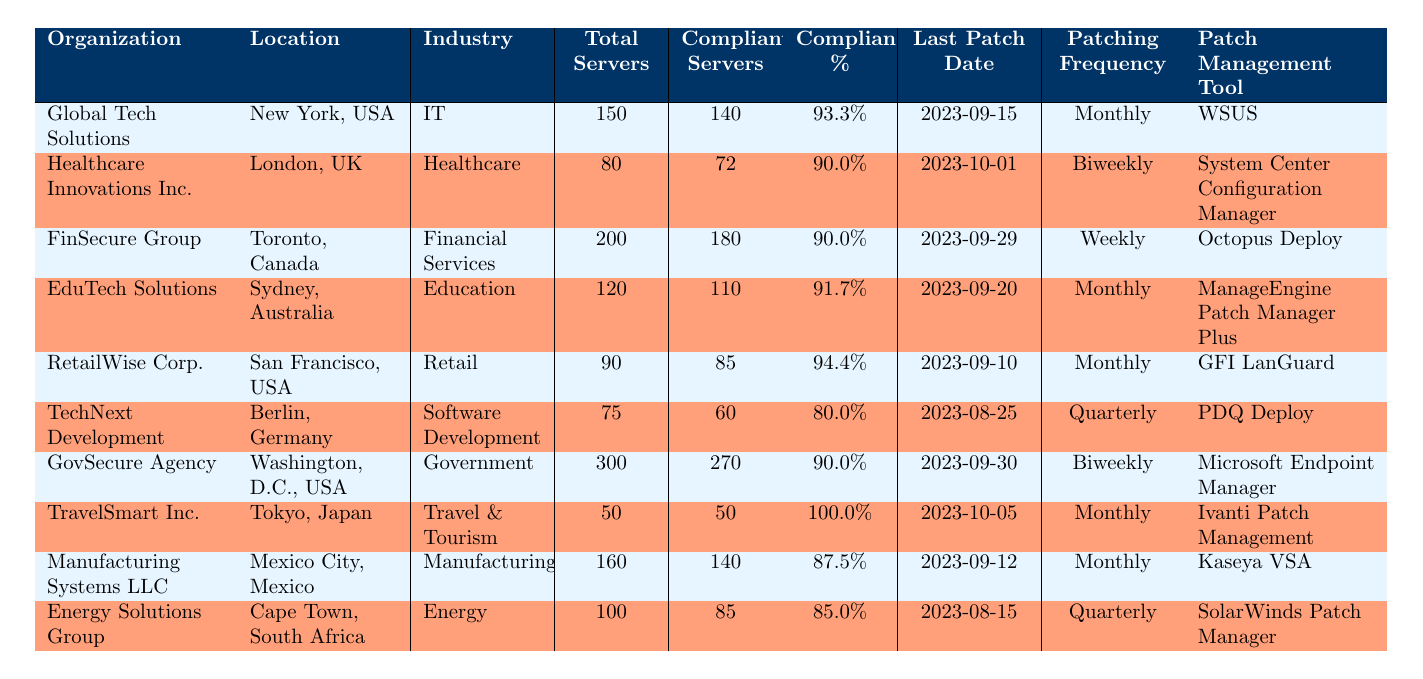What is the compliance percentage of Global Tech Solutions? The table shows "Global Tech Solutions" with a compliance percentage listed under the "Compliance %" column, which is 93.3%.
Answer: 93.3% How many total servers does Healthcare Innovations Inc. have? In the row for "Healthcare Innovations Inc.", the total servers column displays the number 80.
Answer: 80 Which organization has the highest compliance percentage? By comparing the compliance percentages across all organizations listed, "TravelSmart Inc." has a compliance percentage of 100.0%, which is higher than others.
Answer: TravelSmart Inc What is the average number of compliant servers across all organizations? First, we sum the compliant servers: 140 + 72 + 180 + 110 + 85 + 60 + 270 + 50 + 140 + 85 = 1,092. There are 10 organizations, so the average is 1,092 / 10 = 109.2.
Answer: 109.2 Is the last patch date for FinSecure Group later than that of TechNext Development? The last patch date for "FinSecure Group" is 2023-09-29, while for "TechNext Development" it is 2023-08-25. Since 2023-09-29 is later than 2023-08-25, the answer is "yes".
Answer: Yes How many organizations use a monthly patching frequency? By reviewing the table, the organizations with a monthly patching frequency are "Global Tech Solutions", "EduTech Solutions", "RetailWise Corp.", "Manufacturing Systems LLC", and "TravelSmart Inc.". That totals to 5 organizations.
Answer: 5 Which organization's last patch date is the most recent? Looking at the "Last Patch Date" column, "TravelSmart Inc." has the most recent date of 2023-10-05, which is later than any other listed date.
Answer: TravelSmart Inc Does Energy Solutions Group have a higher number of compliant servers than TechNext Development? "Energy Solutions Group" has 85 compliant servers while "TechNext Development" has 60. Since 85 is greater than 60, the answer is "yes".
Answer: Yes What is the difference in compliance percentages between RetailWise Corp. and Manufacturing Systems LLC? The compliance percentage for "RetailWise Corp." is 94.4%, and for "Manufacturing Systems LLC" it is 87.5%. The difference is 94.4 - 87.5 = 6.9%.
Answer: 6.9% 